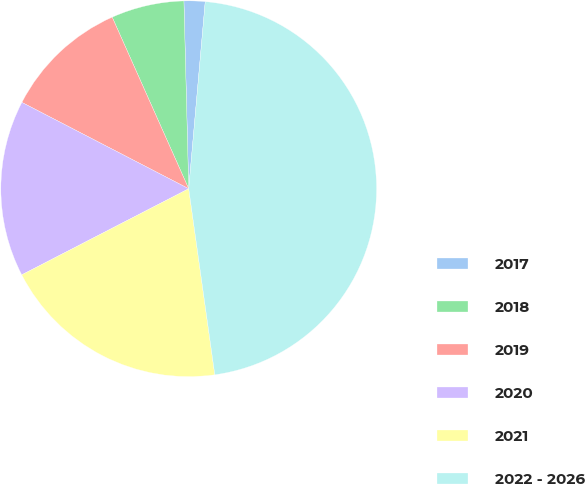Convert chart. <chart><loc_0><loc_0><loc_500><loc_500><pie_chart><fcel>2017<fcel>2018<fcel>2019<fcel>2020<fcel>2021<fcel>2022 - 2026<nl><fcel>1.81%<fcel>6.27%<fcel>10.72%<fcel>15.18%<fcel>19.64%<fcel>46.38%<nl></chart> 